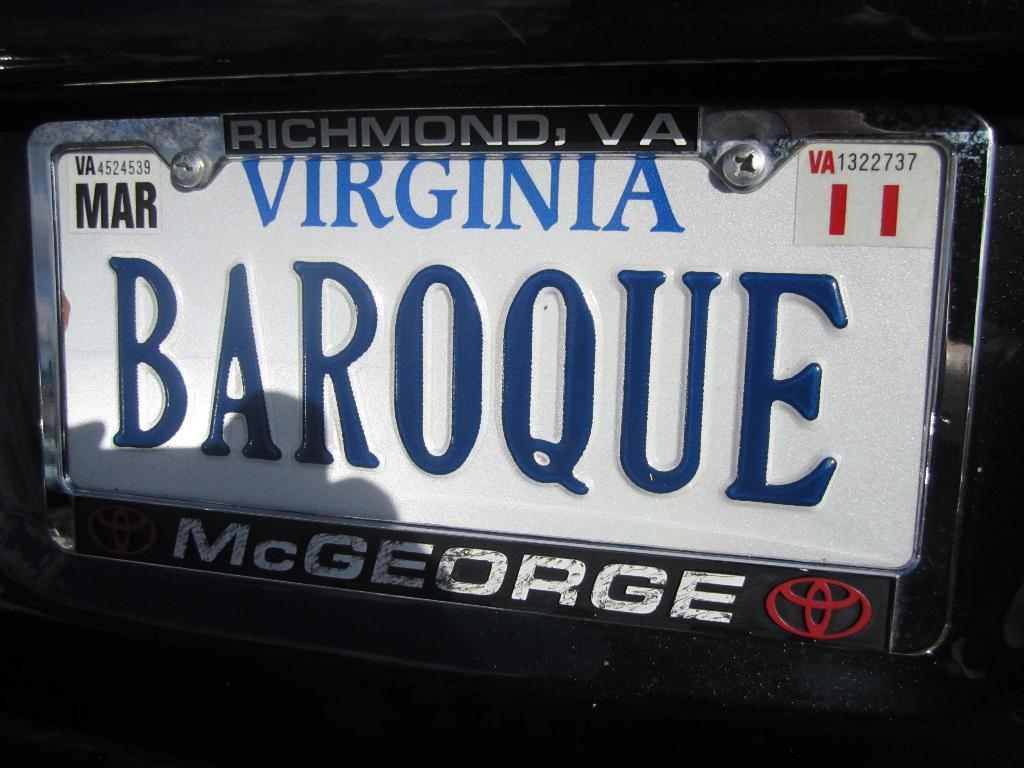<image>
Give a short and clear explanation of the subsequent image. A license plate from Virginia reads, "BAROQUE" and has the Toyota symbol on it. 